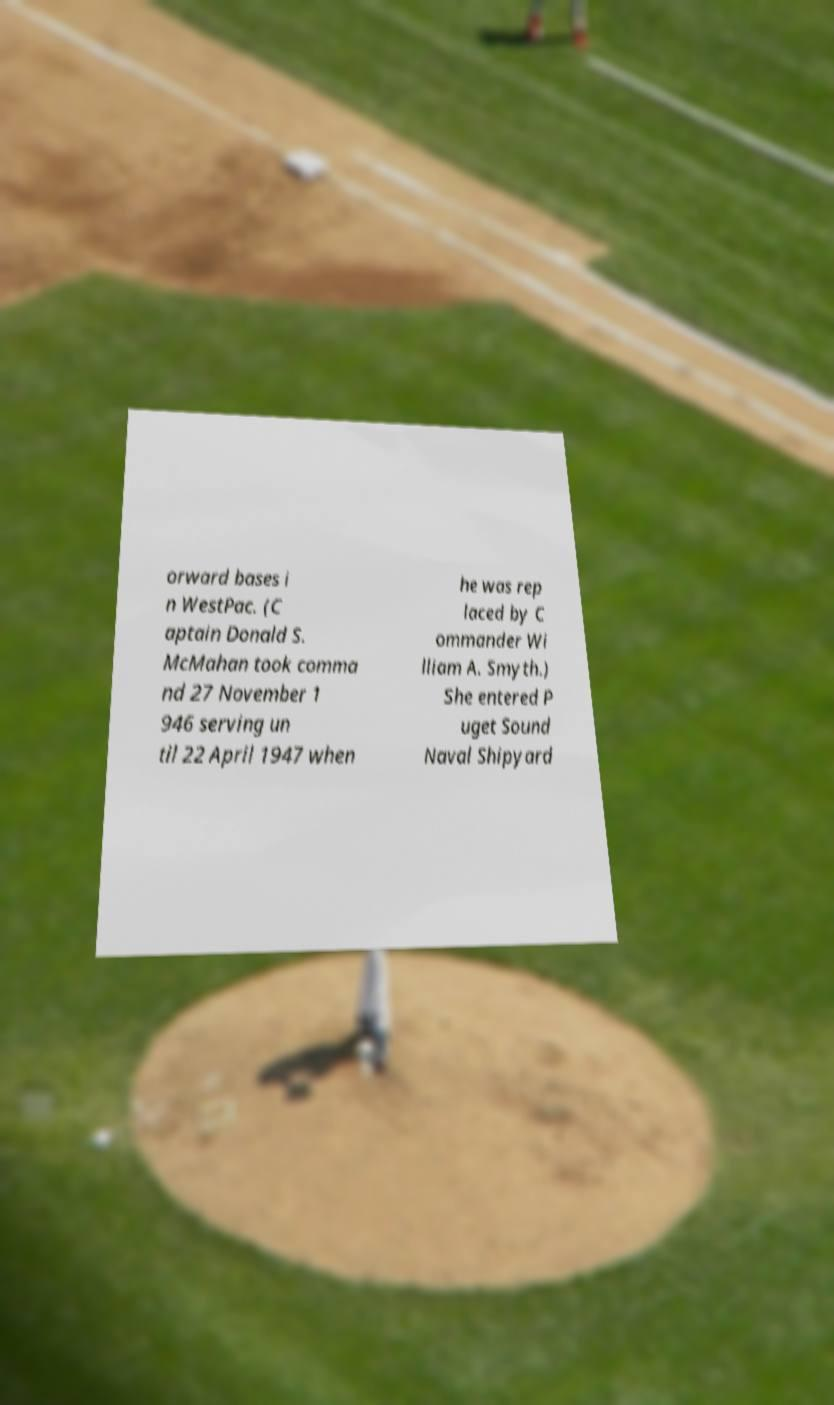What messages or text are displayed in this image? I need them in a readable, typed format. orward bases i n WestPac. (C aptain Donald S. McMahan took comma nd 27 November 1 946 serving un til 22 April 1947 when he was rep laced by C ommander Wi lliam A. Smyth.) She entered P uget Sound Naval Shipyard 